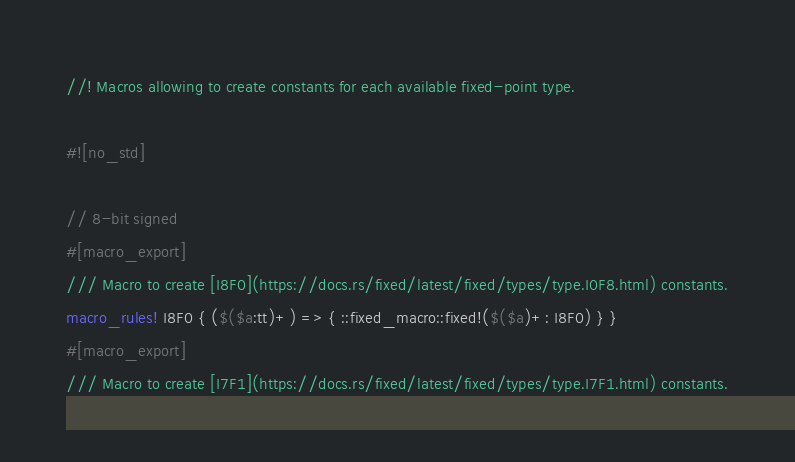<code> <loc_0><loc_0><loc_500><loc_500><_Rust_>//! Macros allowing to create constants for each available fixed-point type.

#![no_std]

// 8-bit signed
#[macro_export]
/// Macro to create [I8F0](https://docs.rs/fixed/latest/fixed/types/type.I0F8.html) constants.
macro_rules! I8F0 { ($($a:tt)+) => { ::fixed_macro::fixed!($($a)+: I8F0) } }
#[macro_export]
/// Macro to create [I7F1](https://docs.rs/fixed/latest/fixed/types/type.I7F1.html) constants.</code> 